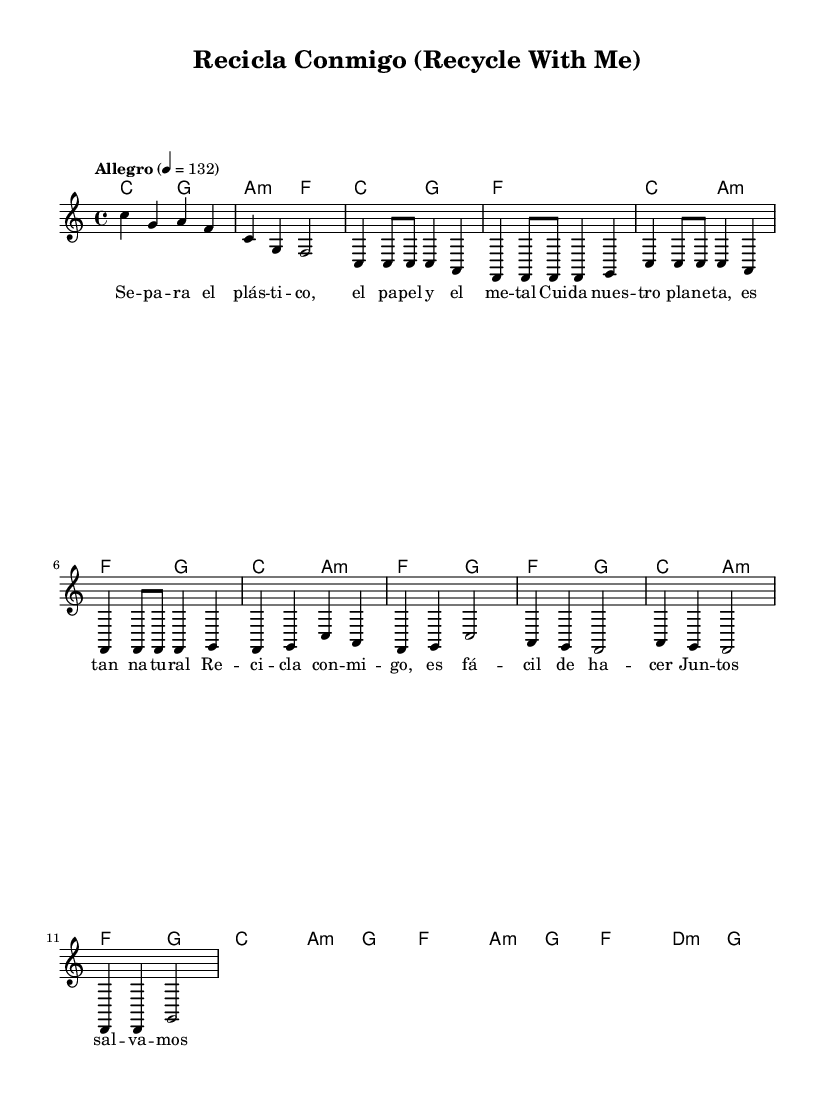What is the key signature of this music? The key signature is C major, which has no sharps or flats.
Answer: C major What is the time signature of the piece? The time signature is indicated by the "4/4" which means there are four beats in a measure and the quarter note gets one beat.
Answer: 4/4 What is the tempo marking for the piece? The tempo marking is written as "Allegro" with a specific metronome mark of 132, indicating the piece should be played fast.
Answer: Allegro 4 = 132 How many measures are in the verse section? By counting the measures from the verse lyrics in the provided melody section, there are 8 measures total in the verse.
Answer: 8 What chords are used in the chorus? The chords used in the chorus are F, G, C, and A minor, based on the chord names written below the melody line.
Answer: F, G, C, A minor What is the primary theme of the lyrics in this piece? The lyrics focus on recycling and caring for the planet, as indicated by phrases like "Reci -- cla con -- mi -- go" and "Cui -- da nues -- tro pla -- ne -- ta."
Answer: Recycling and environmental care What type of musical elements are repeated throughout the song? The song features repetition of melody and chord patterns, particularly in both the verse and the chorus sections, emphasizing the overall message of the song.
Answer: Repetition 